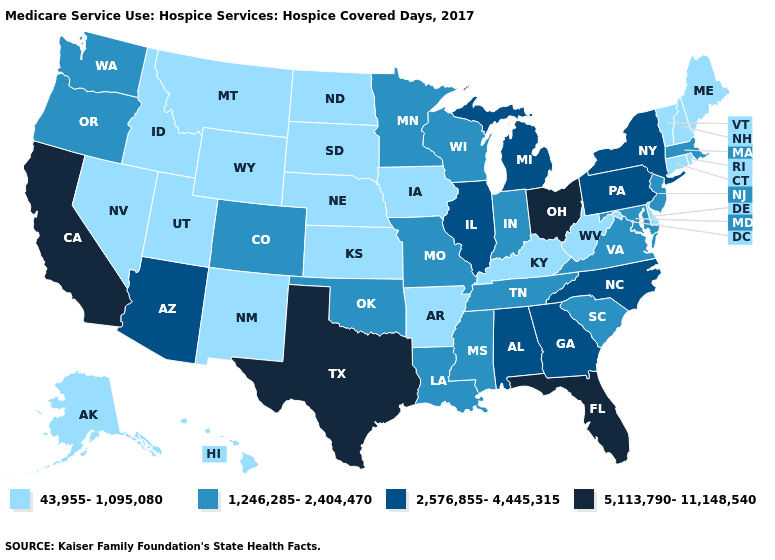Among the states that border Vermont , does New York have the highest value?
Quick response, please. Yes. Among the states that border Connecticut , which have the highest value?
Give a very brief answer. New York. Name the states that have a value in the range 43,955-1,095,080?
Give a very brief answer. Alaska, Arkansas, Connecticut, Delaware, Hawaii, Idaho, Iowa, Kansas, Kentucky, Maine, Montana, Nebraska, Nevada, New Hampshire, New Mexico, North Dakota, Rhode Island, South Dakota, Utah, Vermont, West Virginia, Wyoming. Does the map have missing data?
Write a very short answer. No. How many symbols are there in the legend?
Be succinct. 4. What is the highest value in the USA?
Answer briefly. 5,113,790-11,148,540. Does New Mexico have the lowest value in the USA?
Be succinct. Yes. Does Idaho have the lowest value in the West?
Quick response, please. Yes. Name the states that have a value in the range 5,113,790-11,148,540?
Give a very brief answer. California, Florida, Ohio, Texas. What is the highest value in the South ?
Keep it brief. 5,113,790-11,148,540. Does Kansas have a lower value than Connecticut?
Give a very brief answer. No. What is the value of Pennsylvania?
Keep it brief. 2,576,855-4,445,315. Name the states that have a value in the range 2,576,855-4,445,315?
Quick response, please. Alabama, Arizona, Georgia, Illinois, Michigan, New York, North Carolina, Pennsylvania. What is the value of New Jersey?
Short answer required. 1,246,285-2,404,470. What is the highest value in the MidWest ?
Give a very brief answer. 5,113,790-11,148,540. 